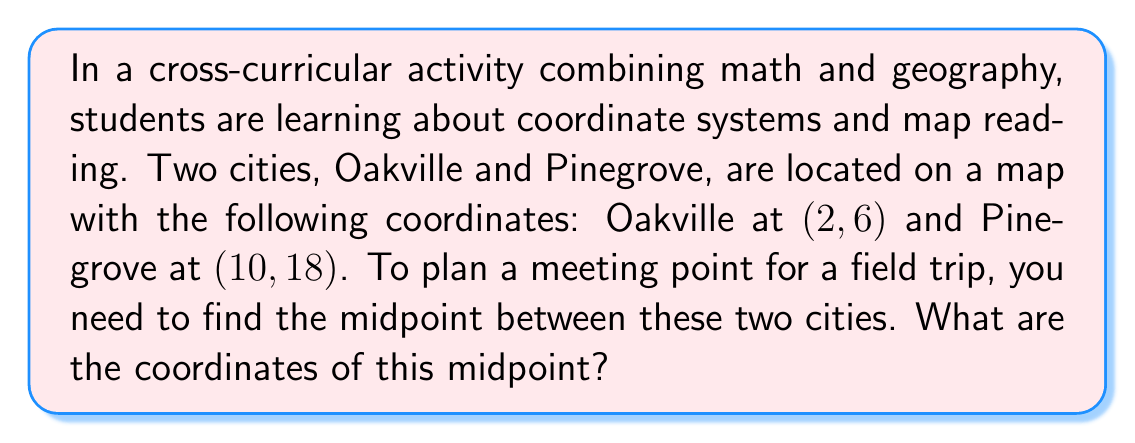Can you answer this question? To find the midpoint of a line segment, we use the midpoint formula:

$$ \text{Midpoint} = \left(\frac{x_1 + x_2}{2}, \frac{y_1 + y_2}{2}\right) $$

Where $(x_1, y_1)$ are the coordinates of the first point and $(x_2, y_2)$ are the coordinates of the second point.

Let's identify our points:
- Oakville: $(x_1, y_1) = (2, 6)$
- Pinegrove: $(x_2, y_2) = (10, 18)$

Now, let's apply the formula:

1. For the x-coordinate of the midpoint:
   $$ \frac{x_1 + x_2}{2} = \frac{2 + 10}{2} = \frac{12}{2} = 6 $$

2. For the y-coordinate of the midpoint:
   $$ \frac{y_1 + y_2}{2} = \frac{6 + 18}{2} = \frac{24}{2} = 12 $$

Therefore, the midpoint coordinates are $(6, 12)$.

[asy]
unitsize(0.5cm);
dot((2,6));
dot((10,18));
dot((6,12),red);
draw((2,6)--(10,18),blue);
label("Oakville (2,6)", (2,6), SW);
label("Pinegrove (10,18)", (10,18), NE);
label("Midpoint (6,12)", (6,12), SE, red);
xaxis(0,12,arrow=Arrow);
yaxis(0,20,arrow=Arrow);
[/asy]
Answer: The coordinates of the midpoint are $(6, 12)$. 